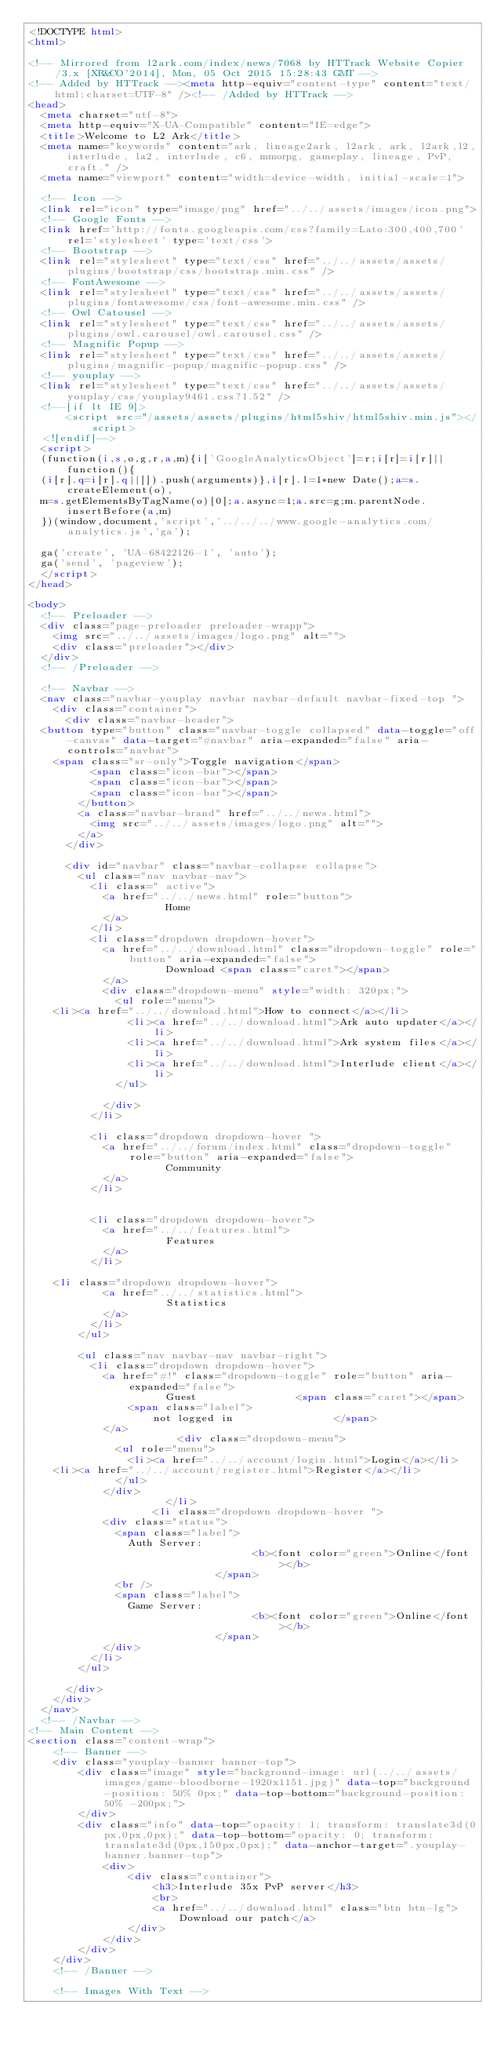Convert code to text. <code><loc_0><loc_0><loc_500><loc_500><_HTML_><!DOCTYPE html>
<html>

<!-- Mirrored from l2ark.com/index/news/7068 by HTTrack Website Copier/3.x [XR&CO'2014], Mon, 05 Oct 2015 15:28:43 GMT -->
<!-- Added by HTTrack --><meta http-equiv="content-type" content="text/html;charset=UTF-8" /><!-- /Added by HTTrack -->
<head>
  <meta charset="utf-8">
  <meta http-equiv="X-UA-Compatible" content="IE=edge">
  <title>Welcome to L2 Ark</title>
  <meta name="keywords" content="ark, lineage2ark, l2ark, ark, l2ark,l2,interlude, la2, interlude, c6, mmorpg, gameplay, lineage, PvP, craft." />
  <meta name="viewport" content="width=device-width, initial-scale=1">

  <!-- Icon -->
  <link rel="icon" type="image/png" href="../../assets/images/icon.png">
  <!-- Google Fonts -->
  <link href='http://fonts.googleapis.com/css?family=Lato:300,400,700' rel='stylesheet' type='text/css'>
  <!-- Bootstrap -->
  <link rel="stylesheet" type="text/css" href="../../assets/assets/plugins/bootstrap/css/bootstrap.min.css" />
  <!-- FontAwesome -->
  <link rel="stylesheet" type="text/css" href="../../assets/assets/plugins/fontawesome/css/font-awesome.min.css" />
  <!-- Owl Catousel -->
  <link rel="stylesheet" type="text/css" href="../../assets/assets/plugins/owl.carousel/owl.carousel.css" />
  <!-- Magnific Popup -->
  <link rel="stylesheet" type="text/css" href="../../assets/assets/plugins/magnific-popup/magnific-popup.css" />
  <!-- youplay -->
  <link rel="stylesheet" type="text/css" href="../../assets/assets/youplay/css/youplay9461.css?1.52" />
  <!--[if lt IE 9]>
      <script src="/assets/assets/plugins/html5shiv/html5shiv.min.js"></script>
  <![endif]-->
  <script>
  (function(i,s,o,g,r,a,m){i['GoogleAnalyticsObject']=r;i[r]=i[r]||function(){
  (i[r].q=i[r].q||[]).push(arguments)},i[r].l=1*new Date();a=s.createElement(o),
  m=s.getElementsByTagName(o)[0];a.async=1;a.src=g;m.parentNode.insertBefore(a,m)
  })(window,document,'script','../../../www.google-analytics.com/analytics.js','ga');

  ga('create', 'UA-68422126-1', 'auto');
  ga('send', 'pageview');
  </script>
</head>

<body>
  <!-- Preloader -->
  <div class="page-preloader preloader-wrapp">
    <img src="../../assets/images/logo.png" alt="">
    <div class="preloader"></div>
  </div>
  <!-- /Preloader -->

  <!-- Navbar -->
  <nav class="navbar-youplay navbar navbar-default navbar-fixed-top "> 
    <div class="container">
      <div class="navbar-header">
	<button type="button" class="navbar-toggle collapsed" data-toggle="off-canvas" data-target="#navbar" aria-expanded="false" aria-controls="navbar">        
	  <span class="sr-only">Toggle navigation</span>
          <span class="icon-bar"></span>
          <span class="icon-bar"></span>
          <span class="icon-bar"></span>
        </button>
        <a class="navbar-brand" href="../../news.html">
          <img src="../../assets/images/logo.png" alt="">
        </a>
      </div>
	 
      <div id="navbar" class="navbar-collapse collapse">
        <ul class="nav navbar-nav">
          <li class=" active">
            <a href="../../news.html" role="button">
                      Home 
            </a>
          </li>
          <li class="dropdown dropdown-hover">
            <a href="../../download.html" class="dropdown-toggle" role="button" aria-expanded="false">
                      Download <span class="caret"></span>
            </a>
            <div class="dropdown-menu" style="width: 320px;">
              <ul role="menu">
		<li><a href="../../download.html">How to connect</a></li>
                <li><a href="../../download.html">Ark auto updater</a></li>
                <li><a href="../../download.html">Ark system files</a></li>
                <li><a href="../../download.html">Interlude client</a></li>
              </ul>

            </div>
          </li>
		  
          <li class="dropdown dropdown-hover ">
            <a href="../../forum/index.html" class="dropdown-toggle" role="button" aria-expanded="false">
                      Community 
            </a>
          </li>
		  
		  
          <li class="dropdown dropdown-hover">
            <a href="../../features.html">
                      Features 
            </a>
          </li>
		  
	  <li class="dropdown dropdown-hover">
            <a href="../../statistics.html">
                      Statistics 
            </a>
          </li>
        </ul>

        <ul class="nav navbar-nav navbar-right">
          <li class="dropdown dropdown-hover">
            <a href="#!" class="dropdown-toggle" role="button" aria-expanded="false">
                      Guest                <span class="caret"></span>
                <span class="label">
                    not logged in                </span>
            </a>
                        <div class="dropdown-menu">
              <ul role="menu">
                <li><a href="../../account/login.html">Login</a></li>
		<li><a href="../../account/register.html">Register</a></li>
              </ul>
            </div>
                      </li>
                    <li class="dropdown dropdown-hover ">
            <div class="status">
              <span class="label">
                Auth Server:
                                    <b><font color="green">Online</font></b>
                              </span>
              <br />
              <span class="label">
                Game Server:
                                    <b><font color="green">Online</font></b>
                              </span>
            </div>
          </li>
        </ul>
	
      </div>
    </div>
  </nav>
  <!-- /Navbar -->
<!-- Main Content -->
<section class="content-wrap">
    <!-- Banner -->
    <div class="youplay-banner banner-top">
        <div class="image" style="background-image: url(../../assets/images/game-bloodborne-1920x1151.jpg)" data-top="background-position: 50% 0px;" data-top-bottom="background-position: 50% -200px;">
        </div>
        <div class="info" data-top="opacity: 1; transform: translate3d(0px,0px,0px);" data-top-bottom="opacity: 0; transform: translate3d(0px,150px,0px);" data-anchor-target=".youplay-banner.banner-top">
            <div>	
                <div class="container">
                    <h3>Interlude 35x PvP server</h3>
                    <br>
                    <a href="../../download.html" class="btn btn-lg">Download our patch</a>
                </div>
            </div>
        </div>
    </div>
    <!-- /Banner -->

    <!-- Images With Text --></code> 